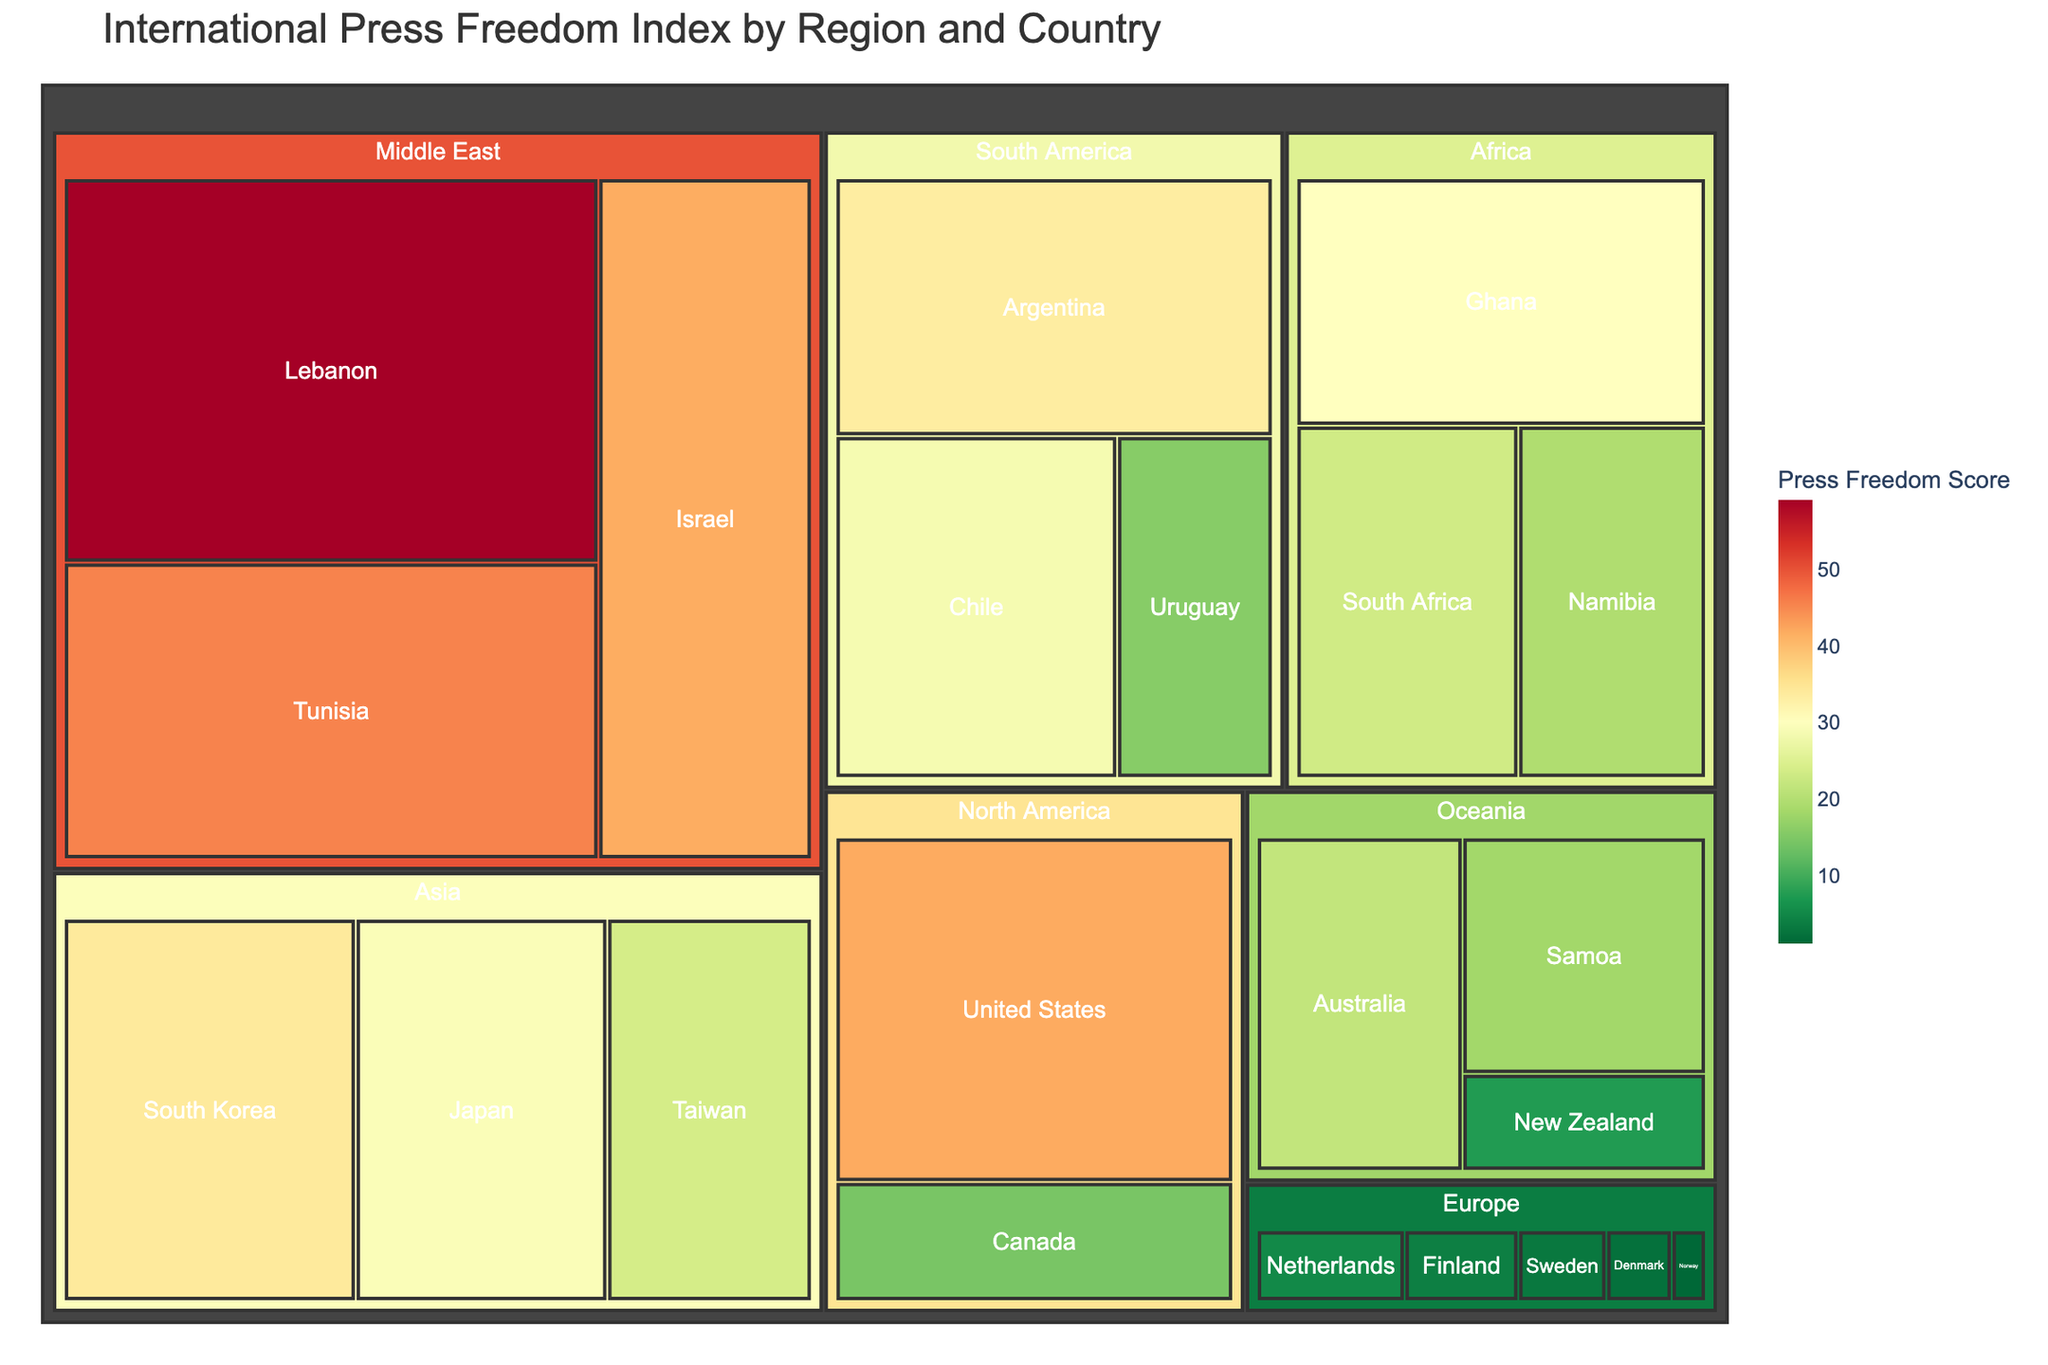What's the title of the treemap? The title of the figure is usually positioned at the top center. In this case, it is "International Press Freedom Index by Region and Country."
Answer: International Press Freedom Index by Region and Country Which country in North America has the lowest Press Freedom Score? In the North America region, by looking at the Press Freedom Scores of the countries, the United States has a score of 42.0, while Canada has a score of 14.5. Therefore, the United States has the lowest Press Freedom Score.
Answer: United States What is the Press Freedom Score for Norway? Norway is in the Europe region. By locating Norway in the figure, we see that its Press Freedom Score is 1.2.
Answer: 1.2 Which region has the highest number of countries displayed in the treemap? Count the number of countries within each region by examining the figure: Europe has 5 countries, North America has 2, South America has 3, Asia has 3, Africa has 3, Middle East has 3, and Oceania has 3. Therefore, Europe has the highest number.
Answer: Europe What is the average Press Freedom Score of countries in Asia? The countries in Asia and their scores are: Japan (29.4), South Korea (34.1), Taiwan (23.9). To get the average: (29.4 + 34.1 + 23.9) / 3 = 29.13.
Answer: 29.13 Which country has the highest Press Freedom Score in the Middle East? By examining the Middle East region, the countries and scores are: Israel (41.8), Lebanon (59.1), Tunisia (45.6). Lebanon has the highest score.
Answer: Lebanon Compare the Press Freedom Scores of any two South American countries. Which has a better score? Comparing Uruguay (15.8) and Argentina (33.5), Uruguay has a better (lower) Press Freedom Score.
Answer: Uruguay What color represents the countries with the highest Press Freedom Scores? In the treemap, a continuous color scale 'RdYlGn_r' is used, where higher scores are represented by red, and lower scores by green. Therefore, the highest scores are represented by red.
Answer: Red Is there any country in Oceania that has a Press Freedom Score higher than 20? By examining the scores in Oceania: New Zealand (7.5), Australia (21.8), Samoa (18.3). Australia has a score higher than 20.
Answer: Yes, Australia Which country has the lowest Press Freedom Score in the entire treemap? By comparing the Press Freedom Scores of all countries, Norway has the lowest score of 1.2.
Answer: Norway 